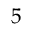<formula> <loc_0><loc_0><loc_500><loc_500>5</formula> 